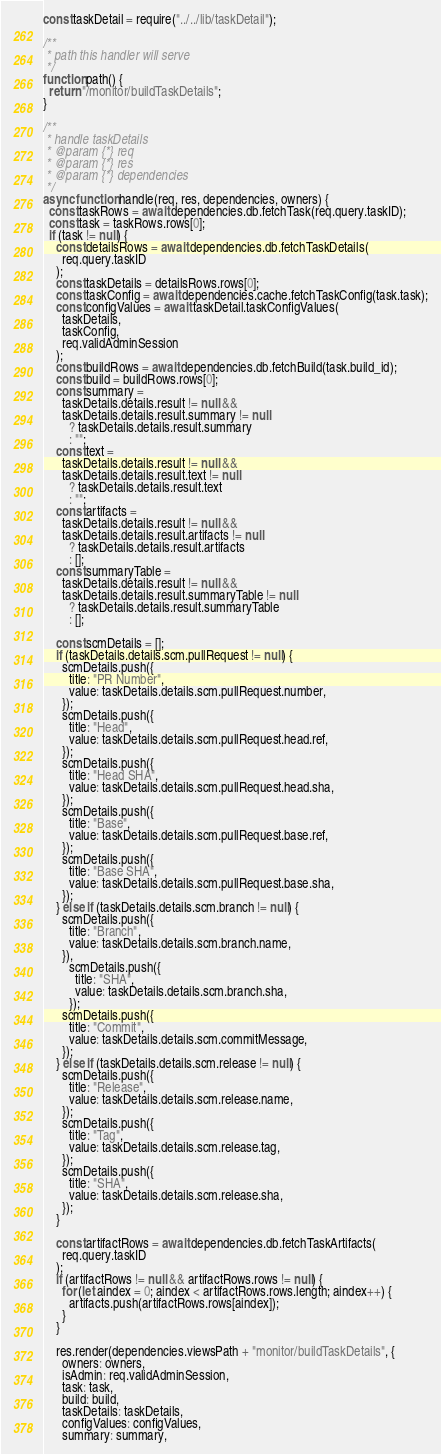<code> <loc_0><loc_0><loc_500><loc_500><_JavaScript_>const taskDetail = require("../../lib/taskDetail");

/**
 * path this handler will serve
 */
function path() {
  return "/monitor/buildTaskDetails";
}

/**
 * handle taskDetails
 * @param {*} req
 * @param {*} res
 * @param {*} dependencies
 */
async function handle(req, res, dependencies, owners) {
  const taskRows = await dependencies.db.fetchTask(req.query.taskID);
  const task = taskRows.rows[0];
  if (task != null) {
    const detailsRows = await dependencies.db.fetchTaskDetails(
      req.query.taskID
    );
    const taskDetails = detailsRows.rows[0];
    const taskConfig = await dependencies.cache.fetchTaskConfig(task.task);
    const configValues = await taskDetail.taskConfigValues(
      taskDetails,
      taskConfig,
      req.validAdminSession
    );
    const buildRows = await dependencies.db.fetchBuild(task.build_id);
    const build = buildRows.rows[0];
    const summary =
      taskDetails.details.result != null &&
      taskDetails.details.result.summary != null
        ? taskDetails.details.result.summary
        : "";
    const text =
      taskDetails.details.result != null &&
      taskDetails.details.result.text != null
        ? taskDetails.details.result.text
        : "";
    const artifacts =
      taskDetails.details.result != null &&
      taskDetails.details.result.artifacts != null
        ? taskDetails.details.result.artifacts
        : [];
    const summaryTable =
      taskDetails.details.result != null &&
      taskDetails.details.result.summaryTable != null
        ? taskDetails.details.result.summaryTable
        : [];

    const scmDetails = [];
    if (taskDetails.details.scm.pullRequest != null) {
      scmDetails.push({
        title: "PR Number",
        value: taskDetails.details.scm.pullRequest.number,
      });
      scmDetails.push({
        title: "Head",
        value: taskDetails.details.scm.pullRequest.head.ref,
      });
      scmDetails.push({
        title: "Head SHA",
        value: taskDetails.details.scm.pullRequest.head.sha,
      });
      scmDetails.push({
        title: "Base",
        value: taskDetails.details.scm.pullRequest.base.ref,
      });
      scmDetails.push({
        title: "Base SHA",
        value: taskDetails.details.scm.pullRequest.base.sha,
      });
    } else if (taskDetails.details.scm.branch != null) {
      scmDetails.push({
        title: "Branch",
        value: taskDetails.details.scm.branch.name,
      }),
        scmDetails.push({
          title: "SHA",
          value: taskDetails.details.scm.branch.sha,
        });
      scmDetails.push({
        title: "Commit",
        value: taskDetails.details.scm.commitMessage,
      });
    } else if (taskDetails.details.scm.release != null) {
      scmDetails.push({
        title: "Release",
        value: taskDetails.details.scm.release.name,
      });
      scmDetails.push({
        title: "Tag",
        value: taskDetails.details.scm.release.tag,
      });
      scmDetails.push({
        title: "SHA",
        value: taskDetails.details.scm.release.sha,
      });
    }

    const artifactRows = await dependencies.db.fetchTaskArtifacts(
      req.query.taskID
    );
    if (artifactRows != null && artifactRows.rows != null) {
      for (let aindex = 0; aindex < artifactRows.rows.length; aindex++) {
        artifacts.push(artifactRows.rows[aindex]);
      }
    }

    res.render(dependencies.viewsPath + "monitor/buildTaskDetails", {
      owners: owners,
      isAdmin: req.validAdminSession,
      task: task,
      build: build,
      taskDetails: taskDetails,
      configValues: configValues,
      summary: summary,</code> 